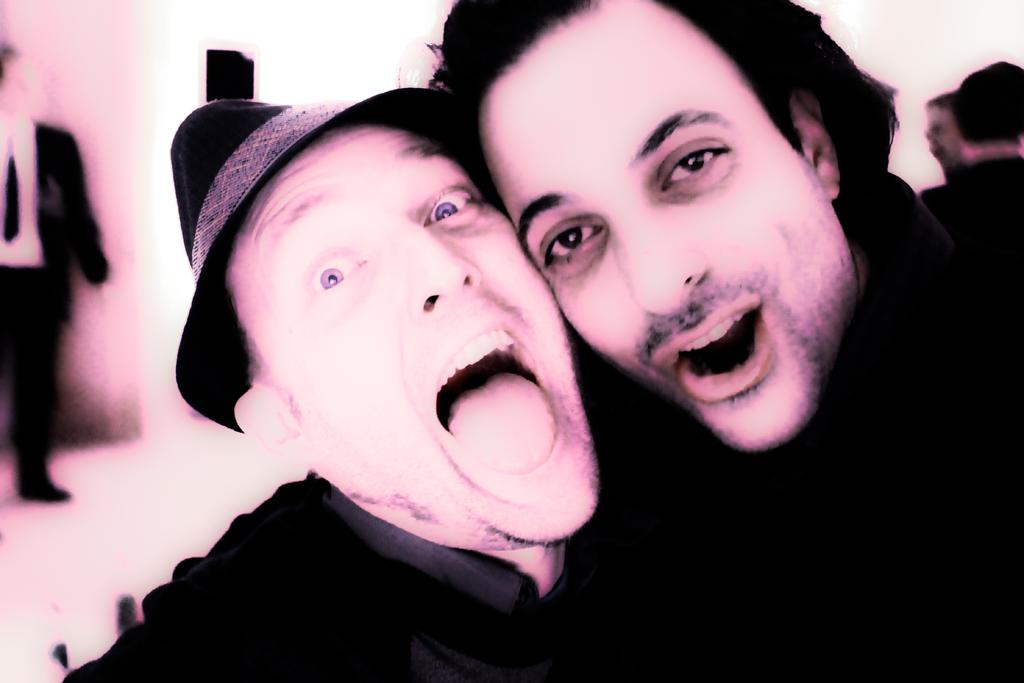How many men are in the front of the image? There are two men in the front of the image. What is one of the men in the front wearing? One of the men in the front is wearing a cap. Can you describe the person in the background of the image? There is a person standing in the background of the image. How would you describe the background of the image? The background of the image appears blurry. What is the price of the baseball bat in the image? There is no baseball bat present in the image, so it is not possible to determine its price. 